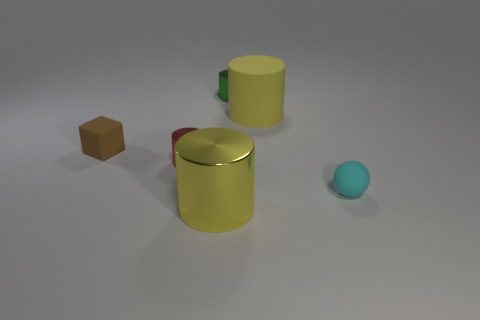Do the red object and the yellow object in front of the matte sphere have the same material? Upon examining the image, it appears that the red and yellow objects, which are a red cylinder with a reflective surface and a yellow cup, do not have the same material. The red cylinder has a glossy finish that is highly reflective, indicative of a material like polished metal. In contrast, the yellow cup displays a less reflective, matte finish that suggests it could be made of a different material, such as plastic or painted metal. 